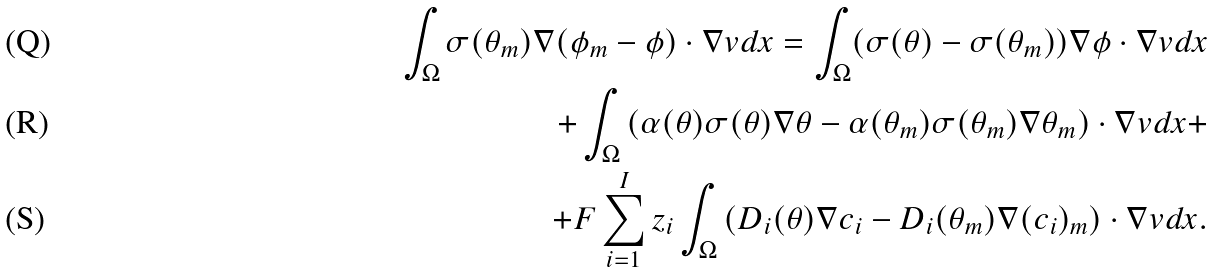<formula> <loc_0><loc_0><loc_500><loc_500>\int _ { \Omega } \sigma ( \theta _ { m } ) \nabla ( \phi _ { m } - \phi ) \cdot \nabla v d x = \int _ { \Omega } ( \sigma ( \theta ) - \sigma ( \theta _ { m } ) ) \nabla \phi \cdot \nabla v d x \\ + \int _ { \Omega } \left ( \alpha ( \theta ) \sigma ( \theta ) \nabla \theta - \alpha ( \theta _ { m } ) \sigma ( \theta _ { m } ) \nabla \theta _ { m } \right ) \cdot \nabla v d x + \\ + F \sum _ { i = 1 } ^ { I } z _ { i } \int _ { \Omega } \left ( D _ { i } ( \theta ) \nabla c _ { i } - D _ { i } ( \theta _ { m } ) \nabla ( c _ { i } ) _ { m } \right ) \cdot \nabla v d x .</formula> 